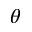<formula> <loc_0><loc_0><loc_500><loc_500>\theta</formula> 